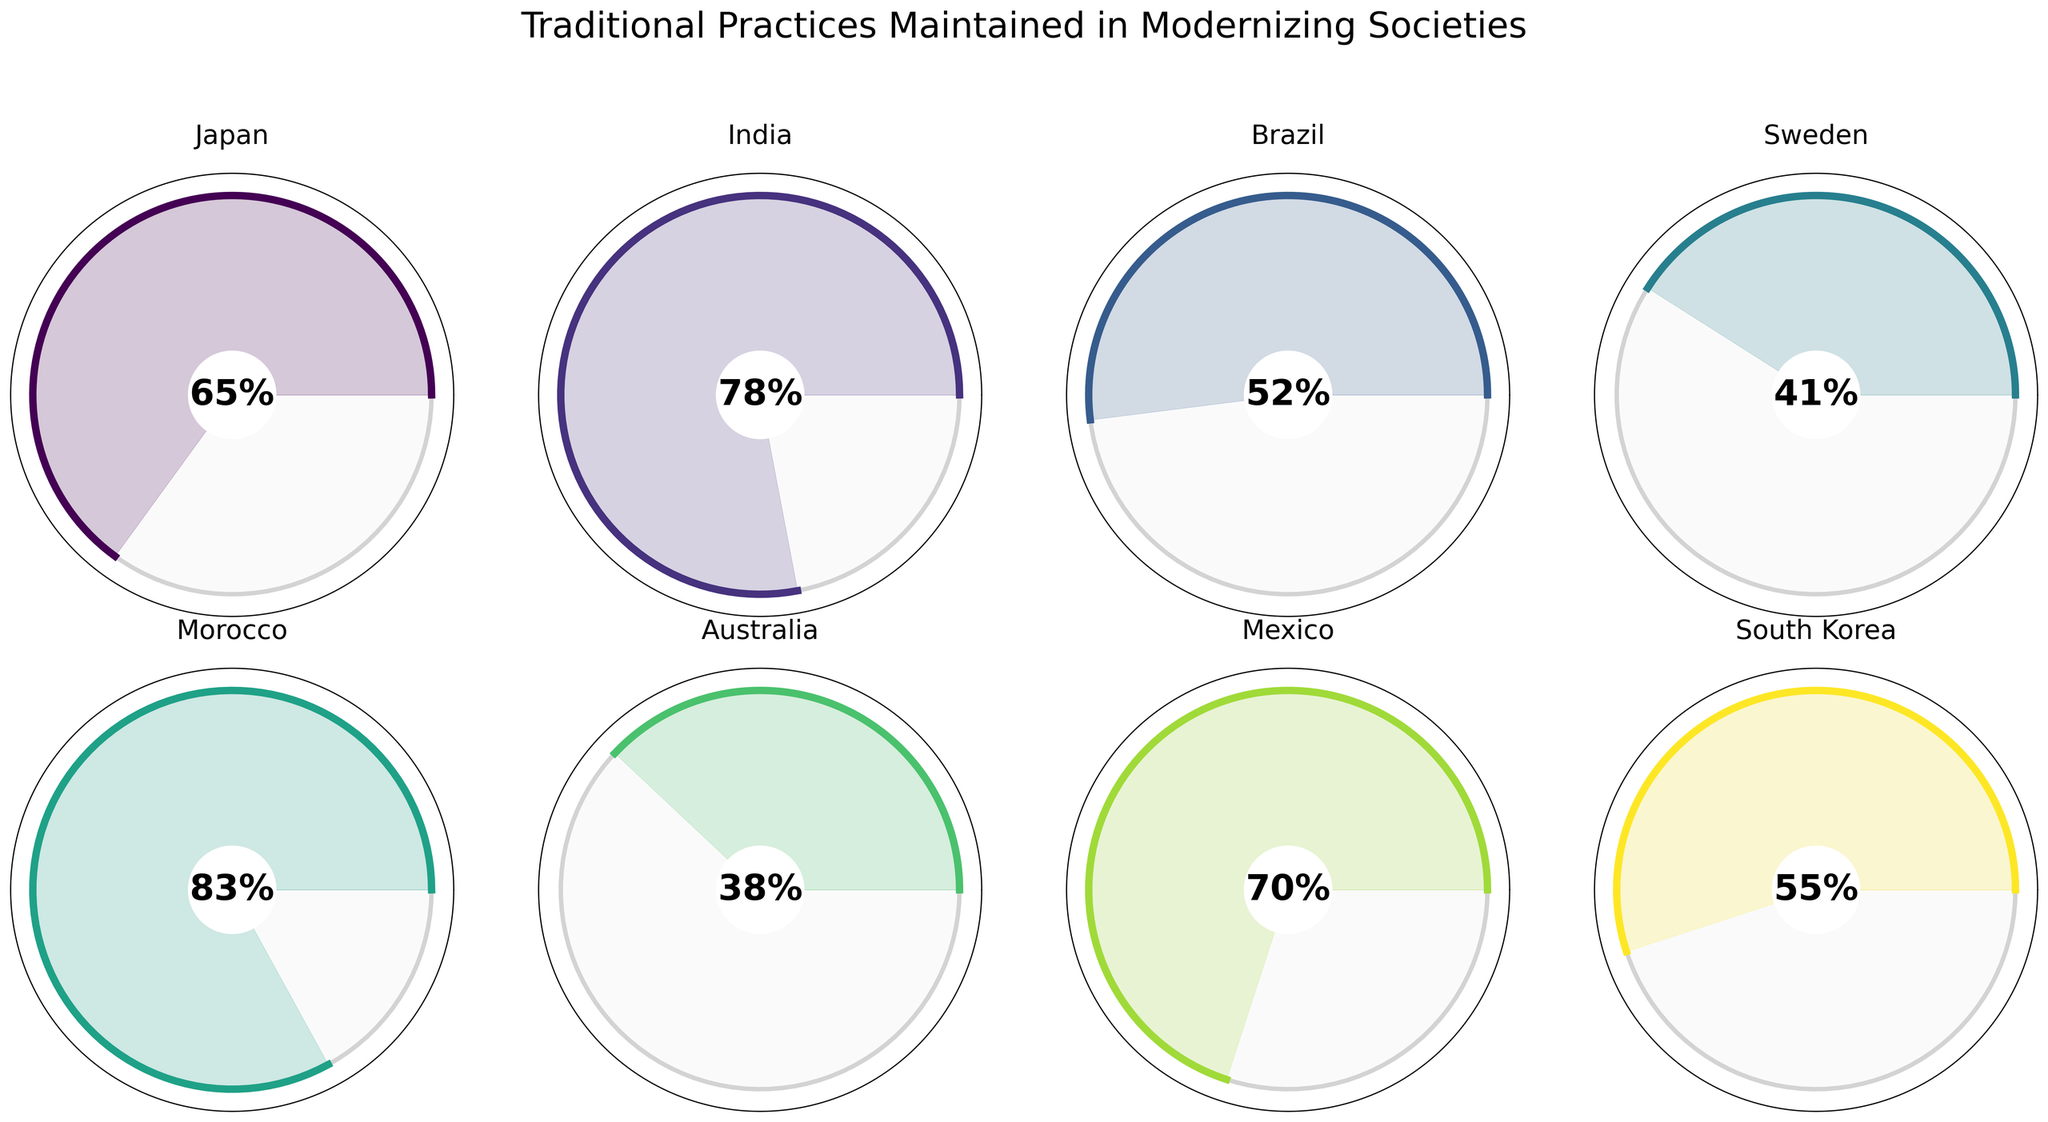What is the highest percentage of traditional practices maintained among the countries shown? The highest percentage can be identified by looking at the gauges and finding the one with the greatest value displayed in the center. Morocco has the highest percentage at 83%.
Answer: 83% Which country has the lowest percentage of traditional practices maintained? To find the lowest value, examine the gauges and identify the one with the smallest value displayed in the center. Australia has the lowest percentage at 38%.
Answer: Australia How many countries have a percentage of traditional practices maintained above 60%? Count the countries whose gauges display values greater than 60. The countries are Japan, India, Morocco, and Mexico. There are 4 such countries.
Answer: 4 Which two countries have the closest percentages of traditional practices maintained? To find the closest values, check the percentages displayed for each country and identify the pair with the smallest difference. South Korea (55%) and Brazil (52%) have the closest percentages, with a difference of 3%.
Answer: South Korea and Brazil What is the average percentage of traditional practices maintained across all countries shown? To calculate the average, sum the percentages and divide by the number of countries. (65 + 78 + 52 + 41 + 83 + 38 + 70 + 55)/8 = 482/8 = 60.25%.
Answer: 60.25% Do any countries have exactly half of their traditional practices maintained? Check if any gauge displays exactly 50%. None of the displayed percentages are 50%.
Answer: No Which country, if any, has a percentage in the range of 40% to 50%? Look for gauges with values within this range. Only Sweden falls in this range with 41%.
Answer: Sweden Compare Brazil and Mexico in terms of traditional practices maintained. Which country has a higher percentage and by how much? Identify the values for both countries and then calculate the difference. Mexico has 70% and Brazil has 52%, thus Mexico has a higher percentage by 18%.
Answer: Mexico, by 18% What is the difference in the percentage of traditional practices maintained between the country with the highest and lowest values? Subtract the lowest value from the highest (83% for Morocco - 38% for Australia). The difference is 45%.
Answer: 45% Which country's gauge shows a similar color to India’s gauge and what is the percentage for that country? Identify the color used for India's gauge and then find another country with a similar color. Mexico has a similar color and the percentage is 70%.
Answer: Mexico, 70% 